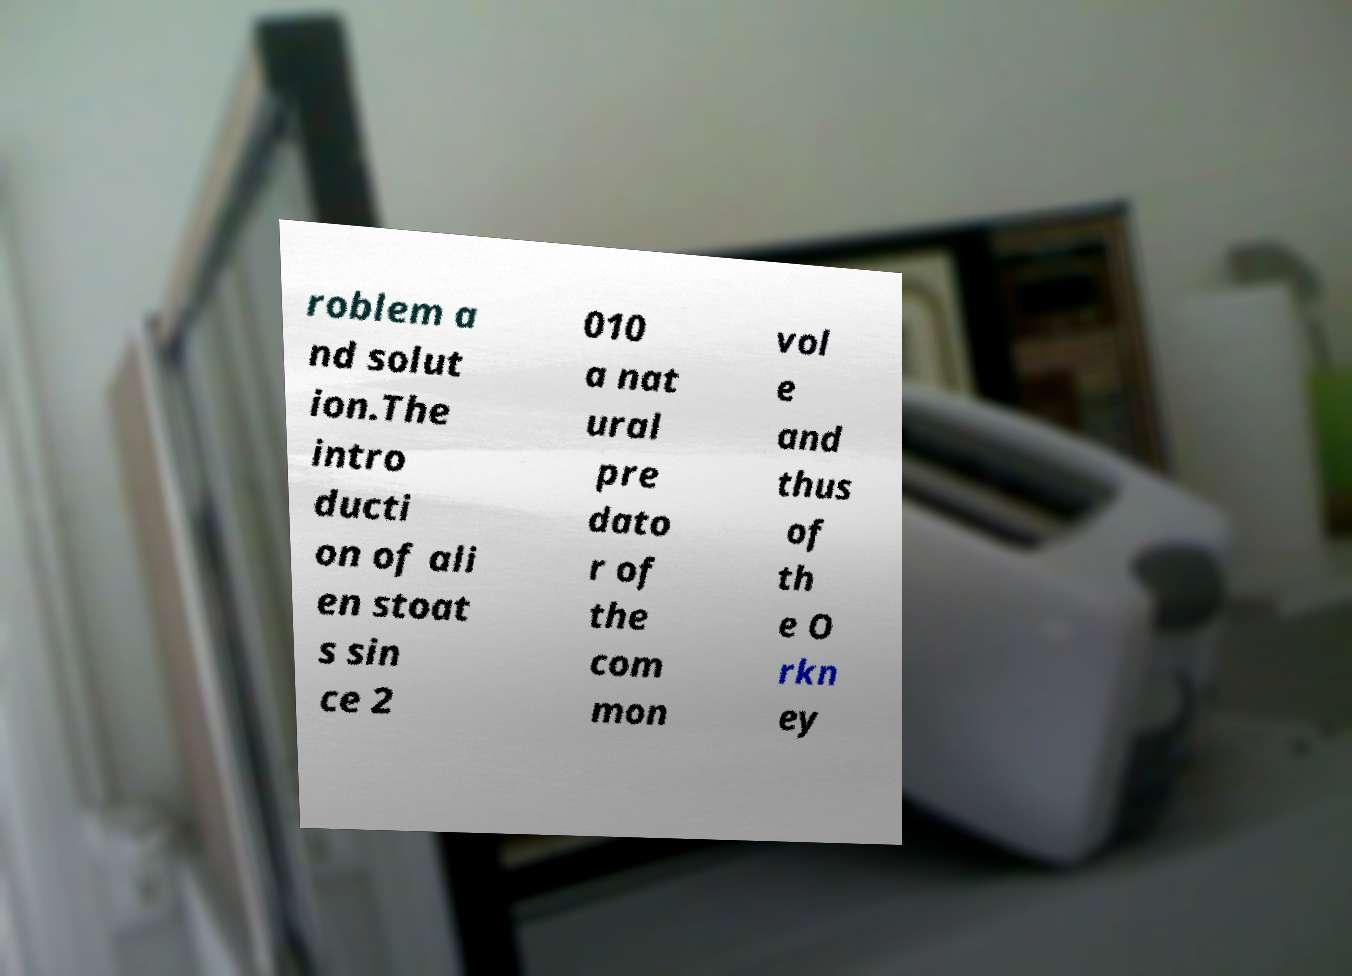For documentation purposes, I need the text within this image transcribed. Could you provide that? roblem a nd solut ion.The intro ducti on of ali en stoat s sin ce 2 010 a nat ural pre dato r of the com mon vol e and thus of th e O rkn ey 